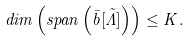<formula> <loc_0><loc_0><loc_500><loc_500>d i m \left ( s p a n \left ( \bar { b } \tilde { \left [ \Lambda \right ] } \right ) \right ) \leq K .</formula> 